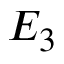Convert formula to latex. <formula><loc_0><loc_0><loc_500><loc_500>E _ { 3 }</formula> 